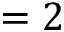<formula> <loc_0><loc_0><loc_500><loc_500>= 2</formula> 